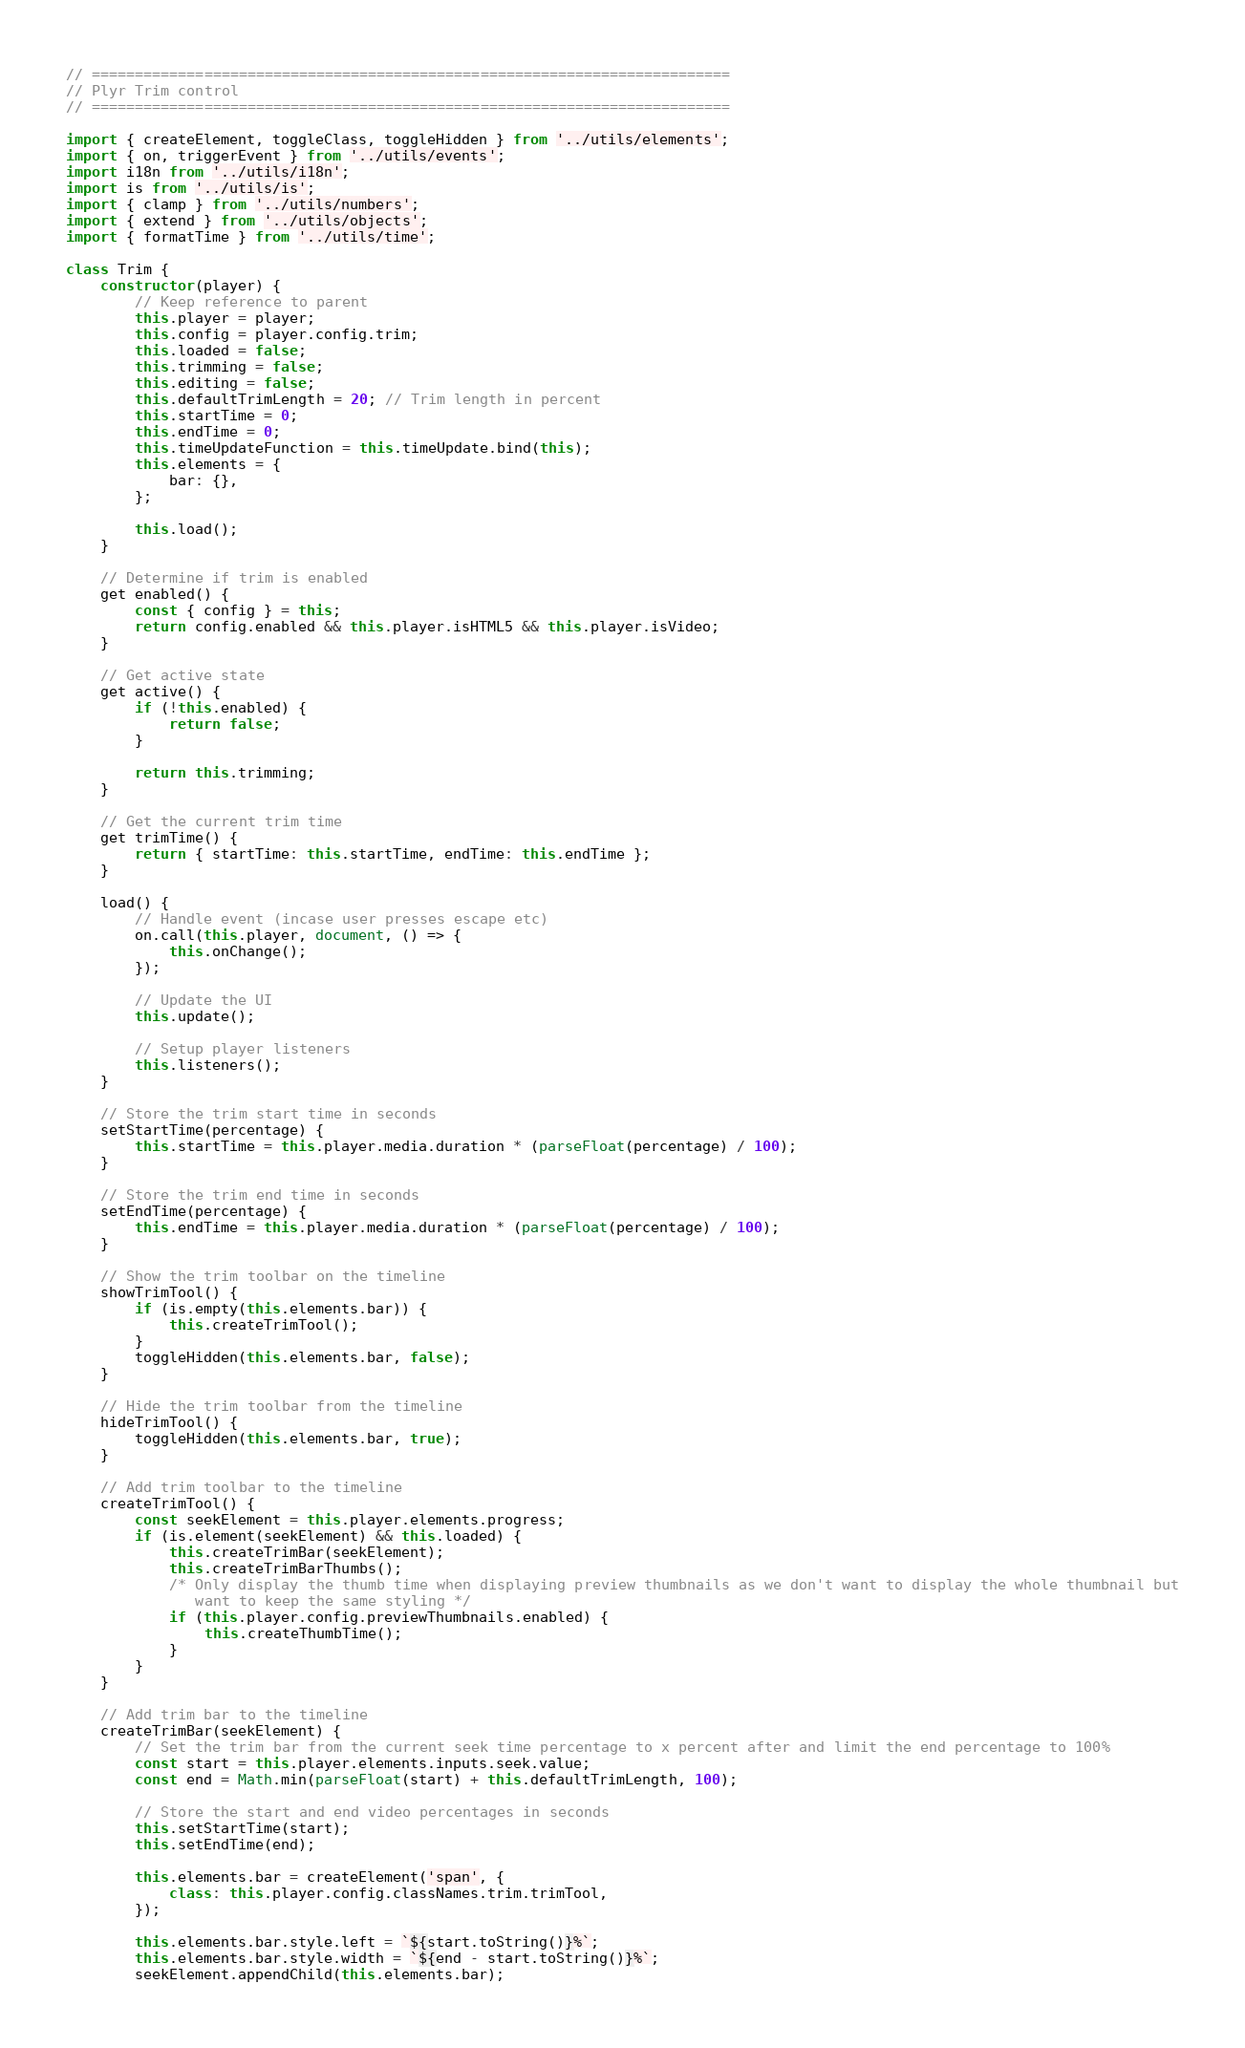Convert code to text. <code><loc_0><loc_0><loc_500><loc_500><_JavaScript_>// ==========================================================================
// Plyr Trim control
// ==========================================================================

import { createElement, toggleClass, toggleHidden } from '../utils/elements';
import { on, triggerEvent } from '../utils/events';
import i18n from '../utils/i18n';
import is from '../utils/is';
import { clamp } from '../utils/numbers';
import { extend } from '../utils/objects';
import { formatTime } from '../utils/time';

class Trim {
    constructor(player) {
        // Keep reference to parent
        this.player = player;
        this.config = player.config.trim;
        this.loaded = false;
        this.trimming = false;
        this.editing = false;
        this.defaultTrimLength = 20; // Trim length in percent
        this.startTime = 0;
        this.endTime = 0;
        this.timeUpdateFunction = this.timeUpdate.bind(this);
        this.elements = {
            bar: {},
        };

        this.load();
    }

    // Determine if trim is enabled
    get enabled() {
        const { config } = this;
        return config.enabled && this.player.isHTML5 && this.player.isVideo;
    }

    // Get active state
    get active() {
        if (!this.enabled) {
            return false;
        }

        return this.trimming;
    }

    // Get the current trim time
    get trimTime() {
        return { startTime: this.startTime, endTime: this.endTime };
    }

    load() {
        // Handle event (incase user presses escape etc)
        on.call(this.player, document, () => {
            this.onChange();
        });

        // Update the UI
        this.update();

        // Setup player listeners
        this.listeners();
    }

    // Store the trim start time in seconds
    setStartTime(percentage) {
        this.startTime = this.player.media.duration * (parseFloat(percentage) / 100);
    }

    // Store the trim end time in seconds
    setEndTime(percentage) {
        this.endTime = this.player.media.duration * (parseFloat(percentage) / 100);
    }

    // Show the trim toolbar on the timeline
    showTrimTool() {
        if (is.empty(this.elements.bar)) {
            this.createTrimTool();
        }
        toggleHidden(this.elements.bar, false);
    }

    // Hide the trim toolbar from the timeline
    hideTrimTool() {
        toggleHidden(this.elements.bar, true);
    }

    // Add trim toolbar to the timeline
    createTrimTool() {
        const seekElement = this.player.elements.progress;
        if (is.element(seekElement) && this.loaded) {
            this.createTrimBar(seekElement);
            this.createTrimBarThumbs();
            /* Only display the thumb time when displaying preview thumbnails as we don't want to display the whole thumbnail but
               want to keep the same styling */
            if (this.player.config.previewThumbnails.enabled) {
                this.createThumbTime();
            }
        }
    }

    // Add trim bar to the timeline
    createTrimBar(seekElement) {
        // Set the trim bar from the current seek time percentage to x percent after and limit the end percentage to 100%
        const start = this.player.elements.inputs.seek.value;
        const end = Math.min(parseFloat(start) + this.defaultTrimLength, 100);

        // Store the start and end video percentages in seconds
        this.setStartTime(start);
        this.setEndTime(end);

        this.elements.bar = createElement('span', {
            class: this.player.config.classNames.trim.trimTool,
        });

        this.elements.bar.style.left = `${start.toString()}%`;
        this.elements.bar.style.width = `${end - start.toString()}%`;
        seekElement.appendChild(this.elements.bar);
</code> 